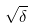<formula> <loc_0><loc_0><loc_500><loc_500>\sqrt { \delta }</formula> 